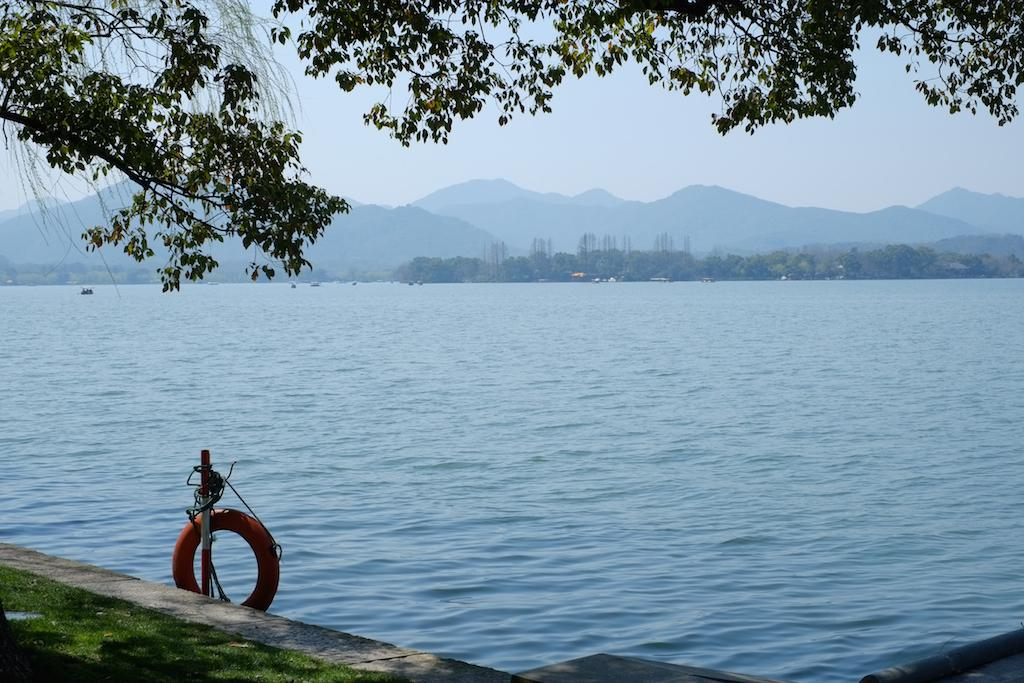What is the primary element present in the image? There is water in the image. What type of natural element can be seen in the image? There is a tree in the image. What man-made object is present in the image? There is a tire in the image. What is visible in the background of the image? The sky is visible in the image. How many dogs are playing with the tire in the image? There are no dogs present in the image; it only features water, a tree, and a tire. 